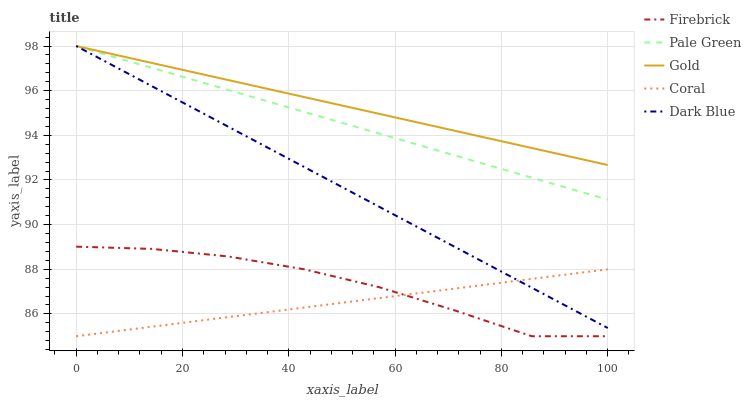Does Coral have the minimum area under the curve?
Answer yes or no. Yes. Does Gold have the maximum area under the curve?
Answer yes or no. Yes. Does Firebrick have the minimum area under the curve?
Answer yes or no. No. Does Firebrick have the maximum area under the curve?
Answer yes or no. No. Is Dark Blue the smoothest?
Answer yes or no. Yes. Is Firebrick the roughest?
Answer yes or no. Yes. Is Pale Green the smoothest?
Answer yes or no. No. Is Pale Green the roughest?
Answer yes or no. No. Does Firebrick have the lowest value?
Answer yes or no. Yes. Does Pale Green have the lowest value?
Answer yes or no. No. Does Gold have the highest value?
Answer yes or no. Yes. Does Firebrick have the highest value?
Answer yes or no. No. Is Coral less than Gold?
Answer yes or no. Yes. Is Dark Blue greater than Firebrick?
Answer yes or no. Yes. Does Pale Green intersect Gold?
Answer yes or no. Yes. Is Pale Green less than Gold?
Answer yes or no. No. Is Pale Green greater than Gold?
Answer yes or no. No. Does Coral intersect Gold?
Answer yes or no. No. 